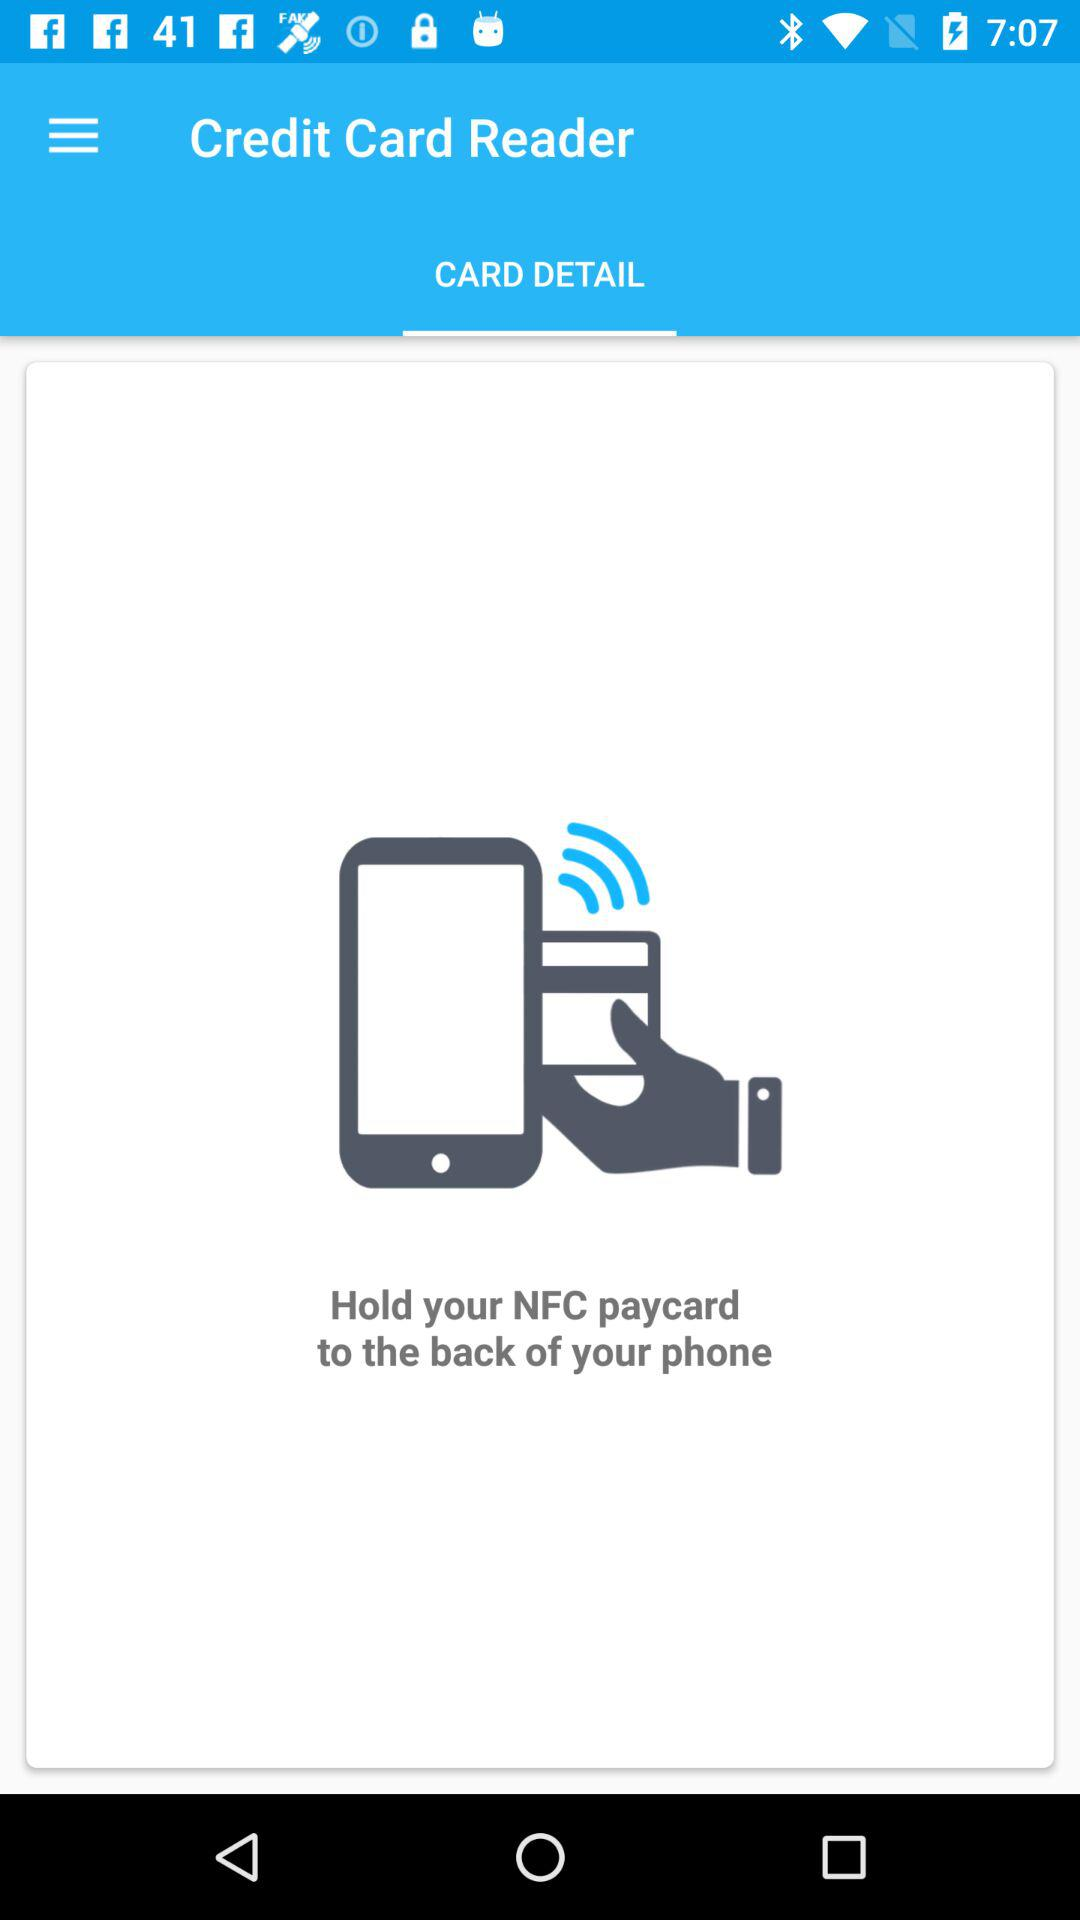What card is needed to be held at the back of the phone? The card that needs to be held is the NFC paycard. 